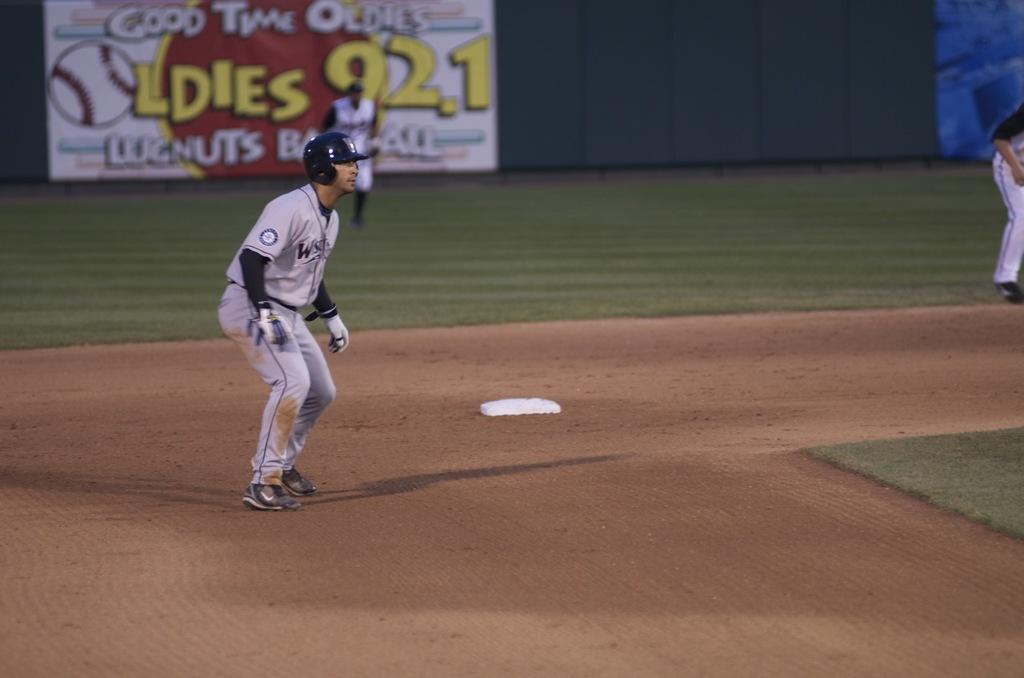Provide a one-sentence caption for the provided image. The sign on the outfield wall advertises for an oldies radio station. 